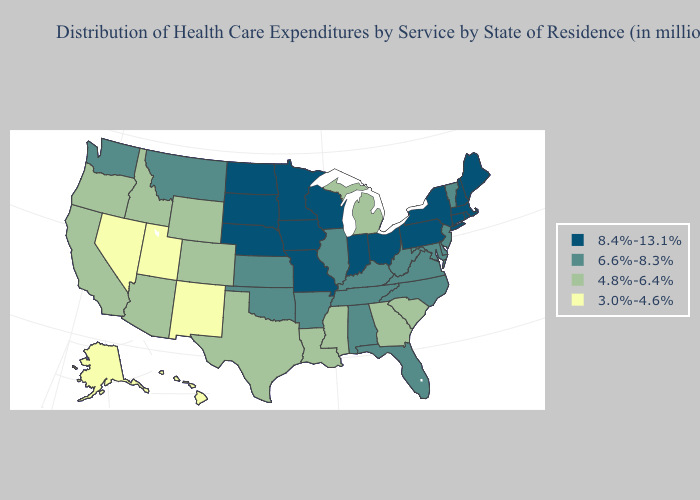What is the value of New York?
Be succinct. 8.4%-13.1%. Among the states that border Idaho , does Utah have the highest value?
Answer briefly. No. Name the states that have a value in the range 3.0%-4.6%?
Be succinct. Alaska, Hawaii, Nevada, New Mexico, Utah. What is the lowest value in states that border Florida?
Short answer required. 4.8%-6.4%. Does Hawaii have the lowest value in the USA?
Write a very short answer. Yes. Among the states that border North Carolina , does Virginia have the lowest value?
Give a very brief answer. No. What is the value of Kentucky?
Answer briefly. 6.6%-8.3%. Which states have the lowest value in the USA?
Quick response, please. Alaska, Hawaii, Nevada, New Mexico, Utah. Does Wyoming have a lower value than North Carolina?
Quick response, please. Yes. Which states have the lowest value in the USA?
Be succinct. Alaska, Hawaii, Nevada, New Mexico, Utah. How many symbols are there in the legend?
Keep it brief. 4. Which states have the lowest value in the West?
Concise answer only. Alaska, Hawaii, Nevada, New Mexico, Utah. What is the highest value in the MidWest ?
Quick response, please. 8.4%-13.1%. What is the highest value in states that border Louisiana?
Be succinct. 6.6%-8.3%. 